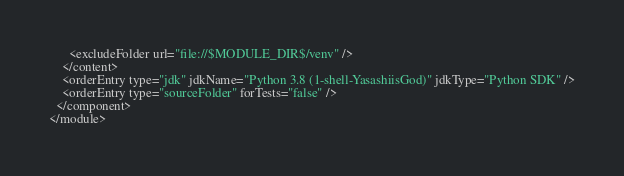<code> <loc_0><loc_0><loc_500><loc_500><_XML_>      <excludeFolder url="file://$MODULE_DIR$/venv" />
    </content>
    <orderEntry type="jdk" jdkName="Python 3.8 (1-shell-YasashiisGod)" jdkType="Python SDK" />
    <orderEntry type="sourceFolder" forTests="false" />
  </component>
</module></code> 